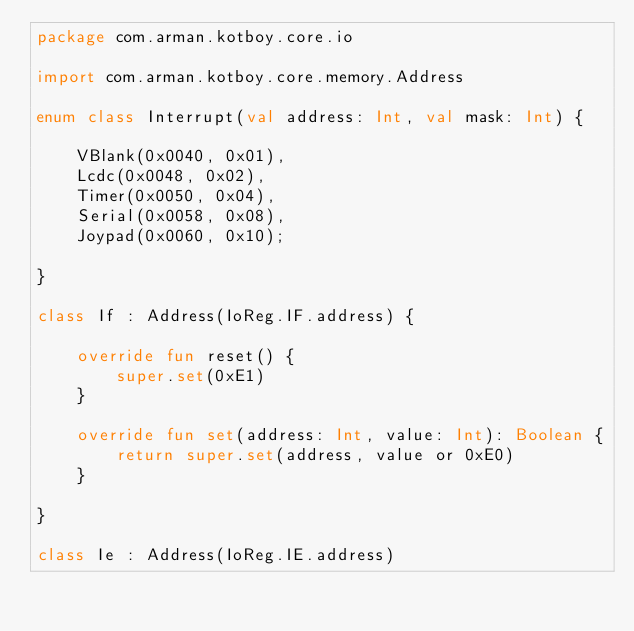Convert code to text. <code><loc_0><loc_0><loc_500><loc_500><_Kotlin_>package com.arman.kotboy.core.io

import com.arman.kotboy.core.memory.Address

enum class Interrupt(val address: Int, val mask: Int) {

    VBlank(0x0040, 0x01),
    Lcdc(0x0048, 0x02),
    Timer(0x0050, 0x04),
    Serial(0x0058, 0x08),
    Joypad(0x0060, 0x10);

}

class If : Address(IoReg.IF.address) {

    override fun reset() {
        super.set(0xE1)
    }

    override fun set(address: Int, value: Int): Boolean {
        return super.set(address, value or 0xE0)
    }

}

class Ie : Address(IoReg.IE.address)</code> 